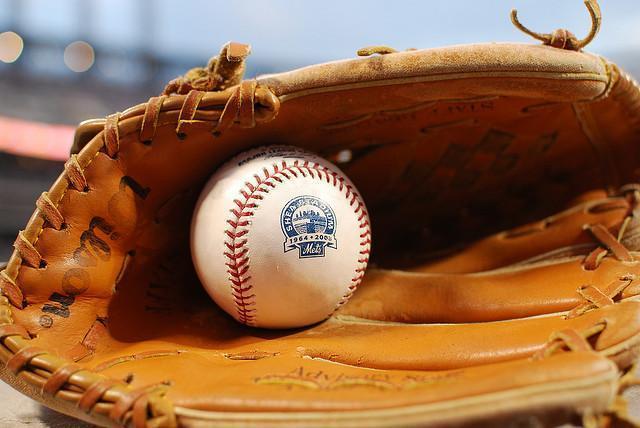How many sports balls are in the photo?
Give a very brief answer. 1. 